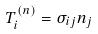<formula> <loc_0><loc_0><loc_500><loc_500>T _ { i } ^ { ( n ) } = \sigma _ { i j } n _ { j }</formula> 